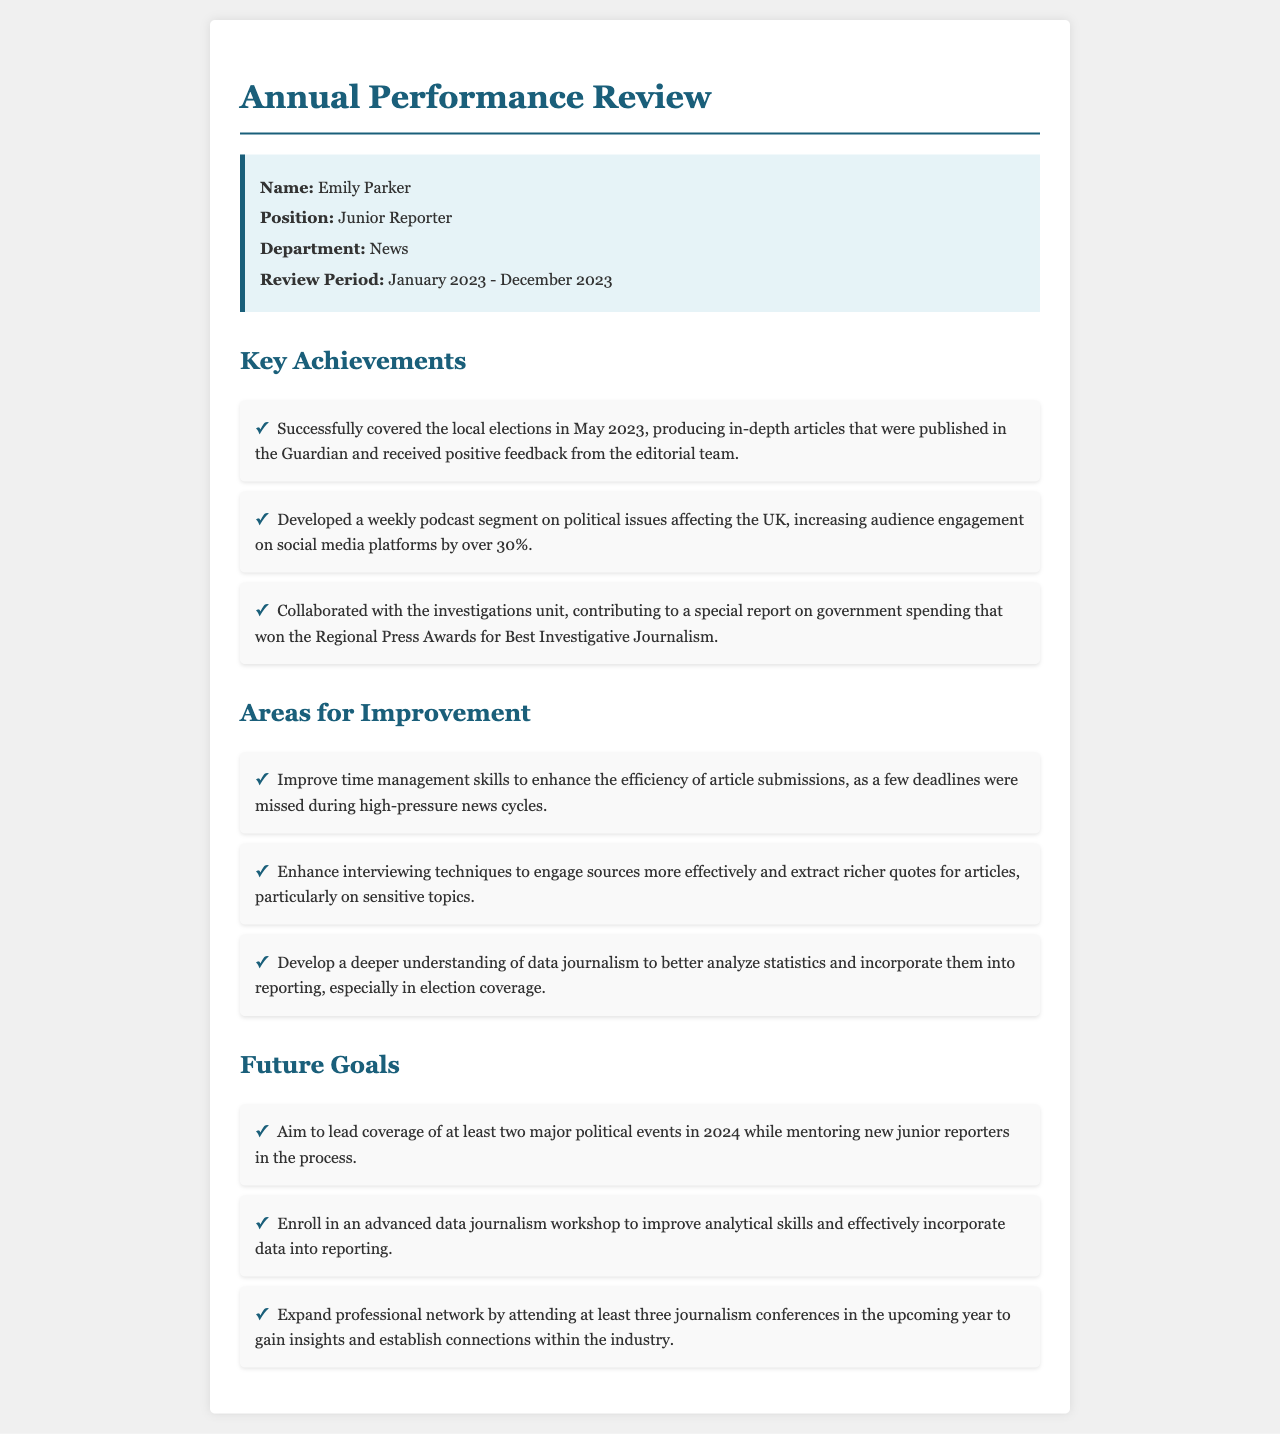What is the name of the junior reporter? The name of the junior reporter is highlighted in the info box under the title "Name."
Answer: Emily Parker What position does Emily Parker hold? Emily Parker's position is clearly stated in the info box under "Position."
Answer: Junior Reporter What department is Emily Parker part of? The department is specified in the info box that lists her details.
Answer: News What was the review period for Emily Parker’s performance? The review period is indicated in the info box under "Review Period."
Answer: January 2023 - December 2023 How many major political events does Emily aim to lead coverage of in 2024? The goal regarding the number of events is mentioned under the "Future Goals" section.
Answer: Two What percentage increase in audience engagement did the podcast segment achieve? This percentage is noted specifically in the "Key Achievements" section.
Answer: Over 30% Which award did the special report on government spending win? The award is mentioned in the "Key Achievements" section regarding the collaboration with the investigations unit.
Answer: Best Investigative Journalism What skill does Emily need to improve related to article submissions? This is listed in the "Areas for Improvement" section where specific skills are described.
Answer: Time management What type of workshop does Emily plan to enroll in? The type of workshop is clearly stated under "Future Goals."
Answer: Advanced data journalism How many journalism conferences does Emily intend to attend in the upcoming year? This number is specified in the "Future Goals" section.
Answer: Three 